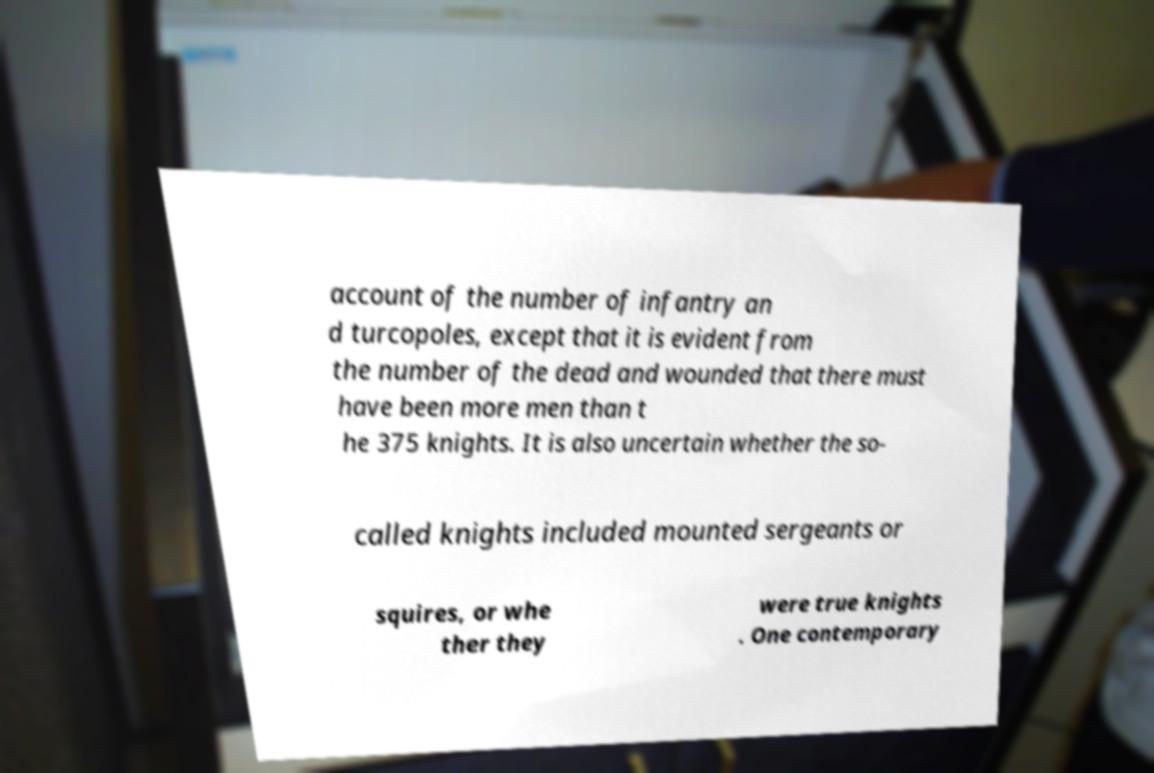What messages or text are displayed in this image? I need them in a readable, typed format. account of the number of infantry an d turcopoles, except that it is evident from the number of the dead and wounded that there must have been more men than t he 375 knights. It is also uncertain whether the so- called knights included mounted sergeants or squires, or whe ther they were true knights . One contemporary 